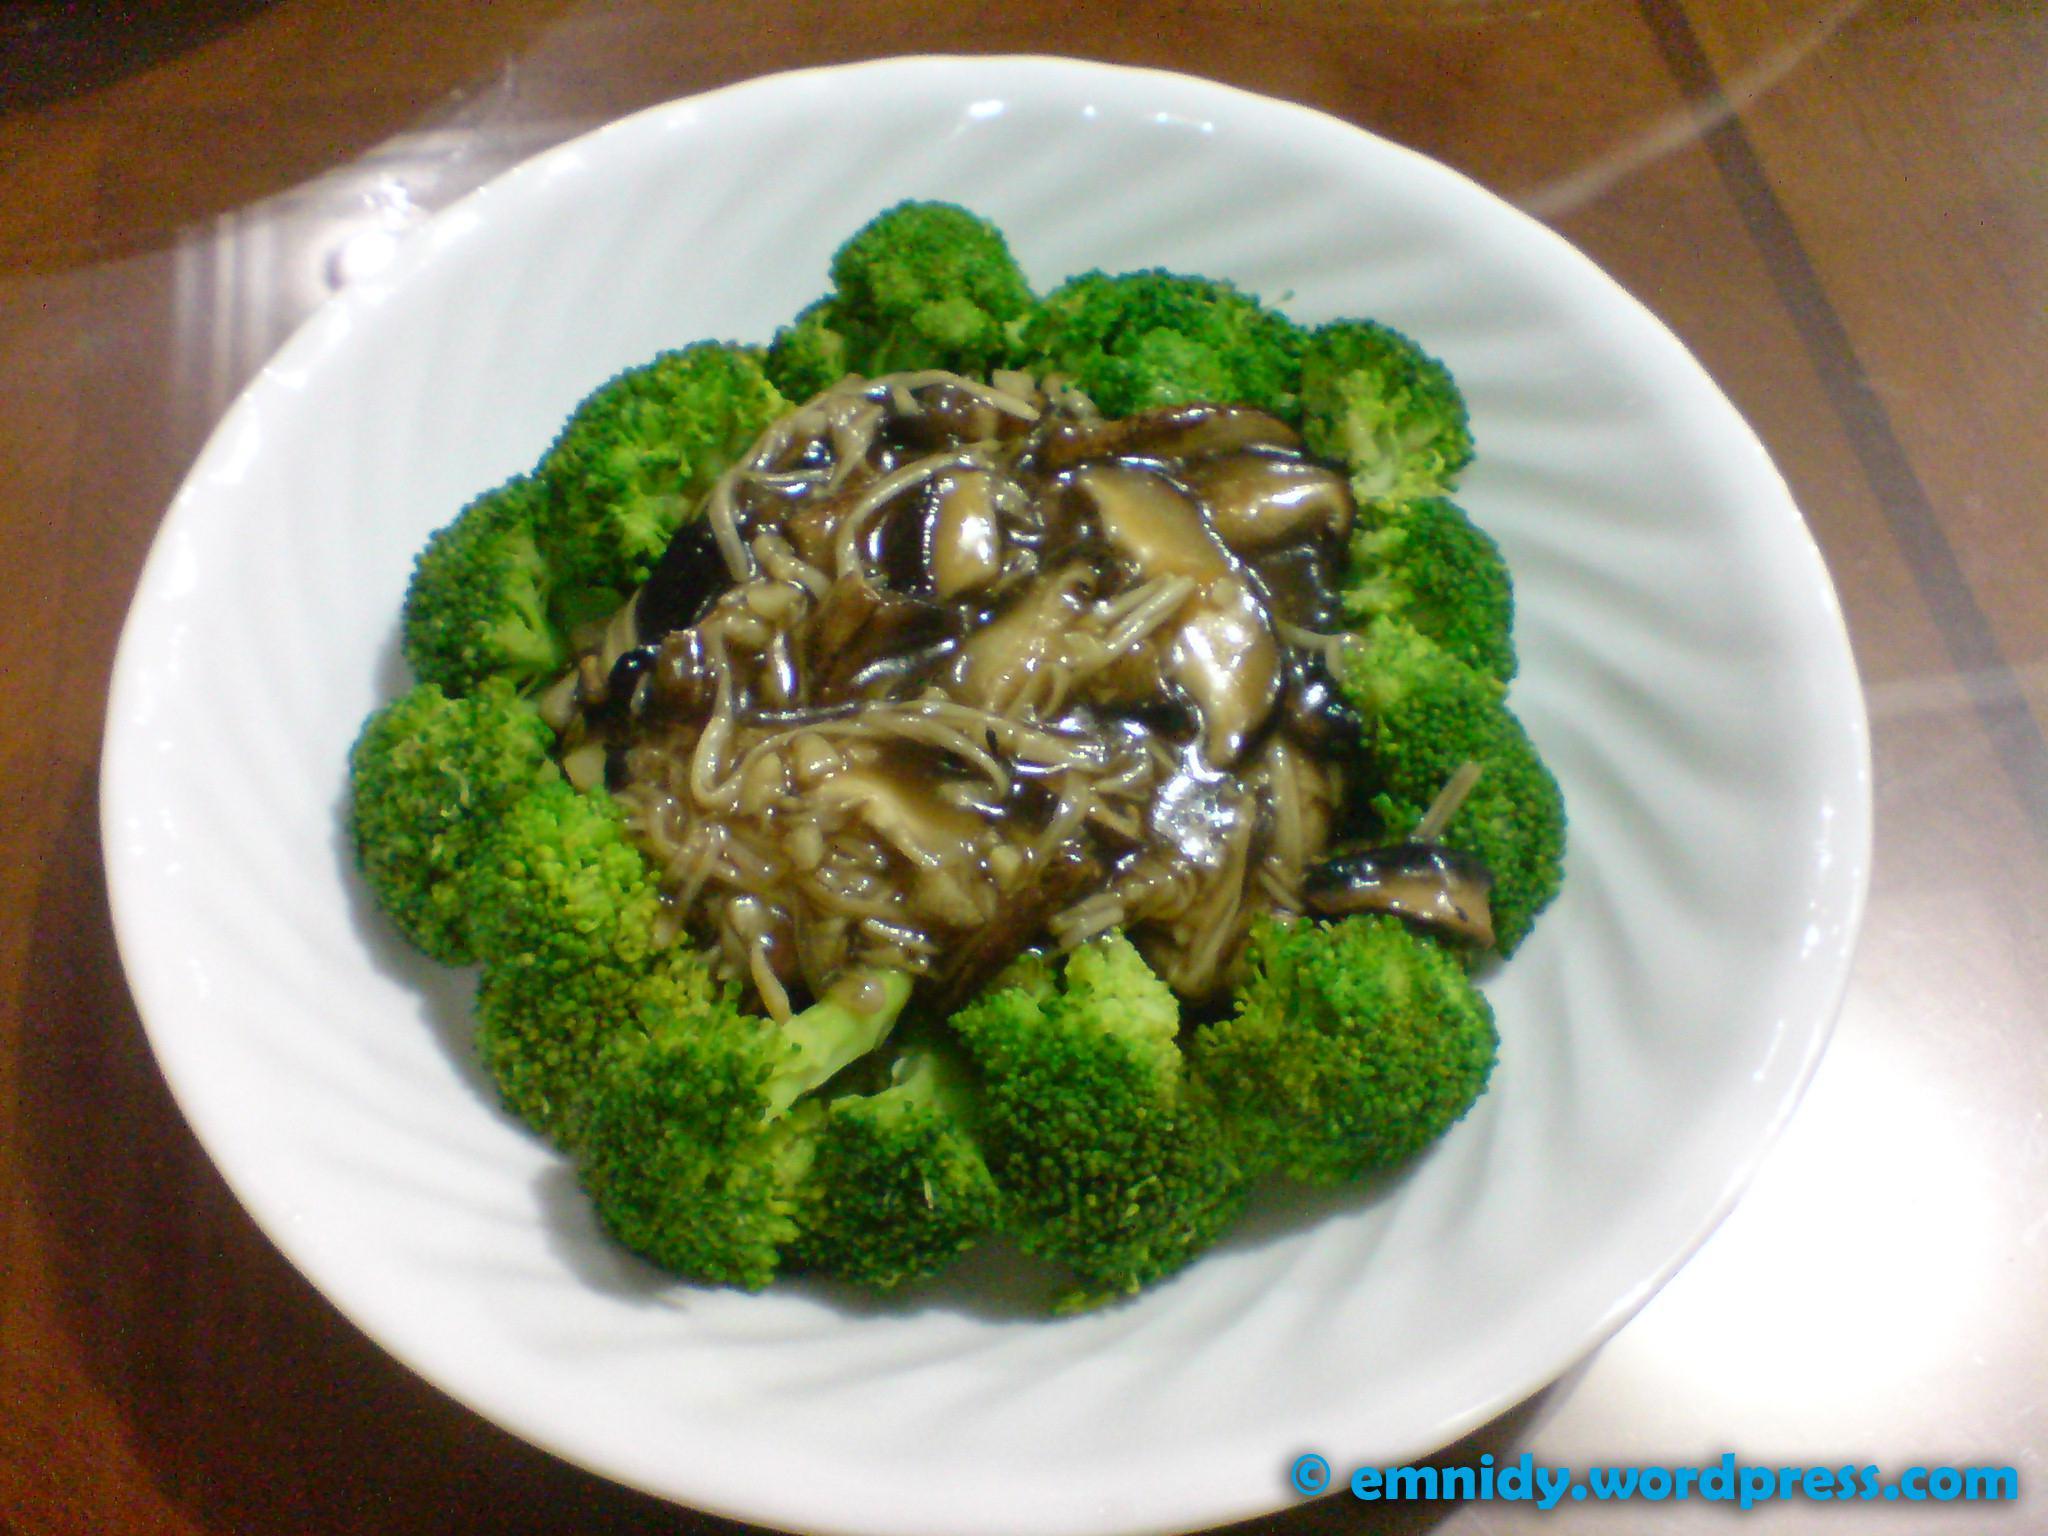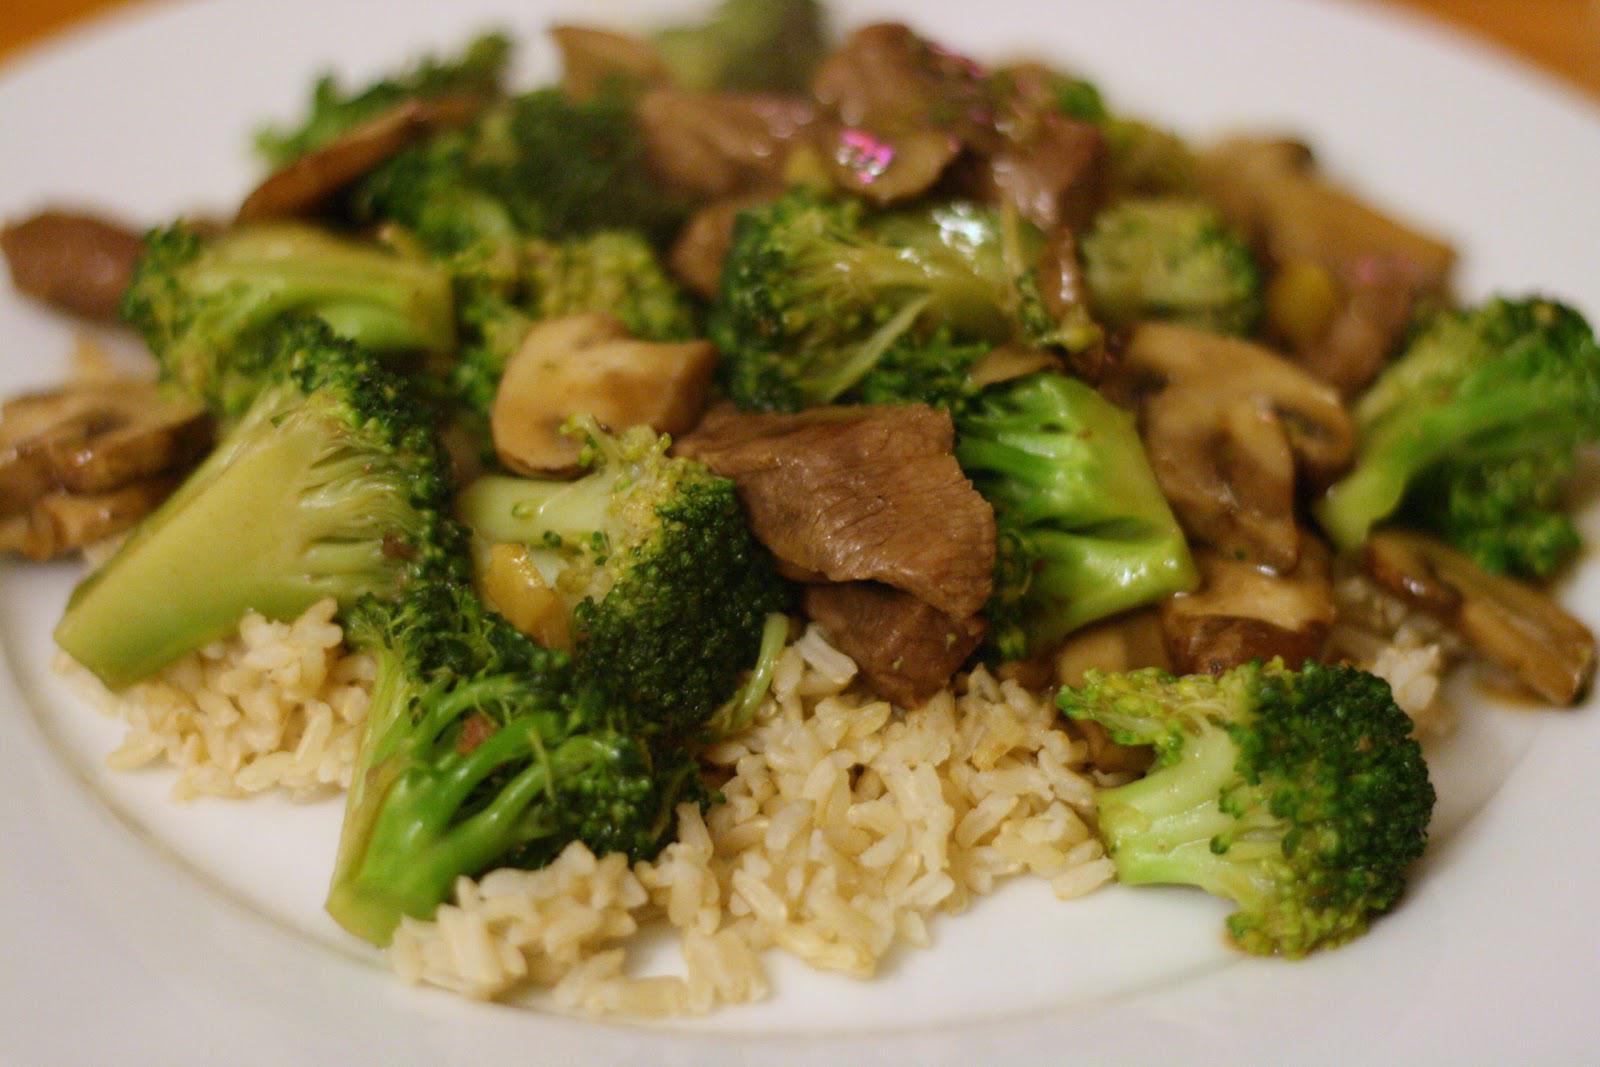The first image is the image on the left, the second image is the image on the right. Evaluate the accuracy of this statement regarding the images: "There is rice in the image on the right.". Is it true? Answer yes or no. Yes. The first image is the image on the left, the second image is the image on the right. Considering the images on both sides, is "At least one image shows a broccoli dish served on an all white plate, with no colored trim." valid? Answer yes or no. Yes. 